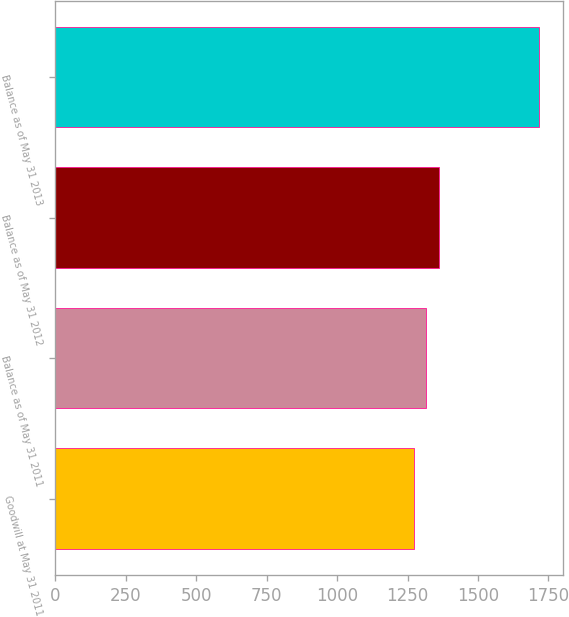<chart> <loc_0><loc_0><loc_500><loc_500><bar_chart><fcel>Goodwill at May 31 2011<fcel>Balance as of May 31 2011<fcel>Balance as of May 31 2012<fcel>Balance as of May 31 2013<nl><fcel>1272<fcel>1316.3<fcel>1360.6<fcel>1715<nl></chart> 